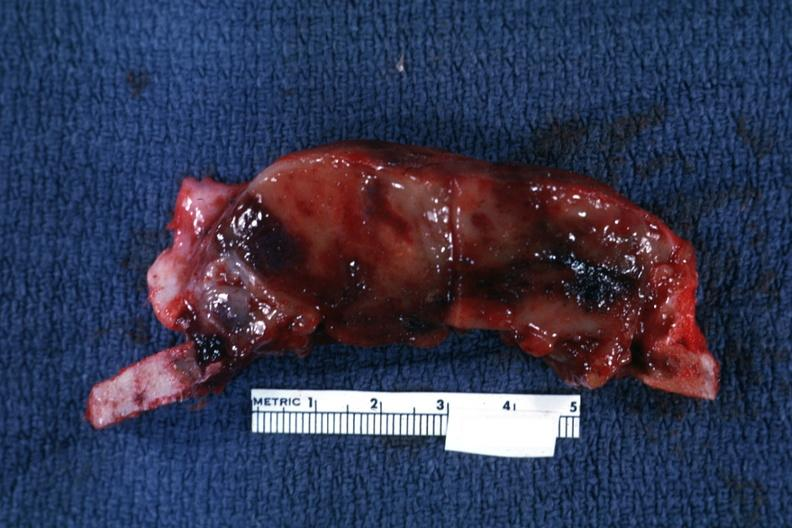does meningioma show section of calvarium?
Answer the question using a single word or phrase. No 